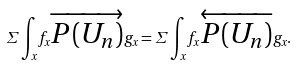<formula> <loc_0><loc_0><loc_500><loc_500>\Sigma \int _ { x } f _ { x } \overrightarrow { P ( U _ { n } ) } g _ { x } = \Sigma \int _ { x } f _ { x } \overleftarrow { P ( U _ { n } ) } g _ { x } .</formula> 